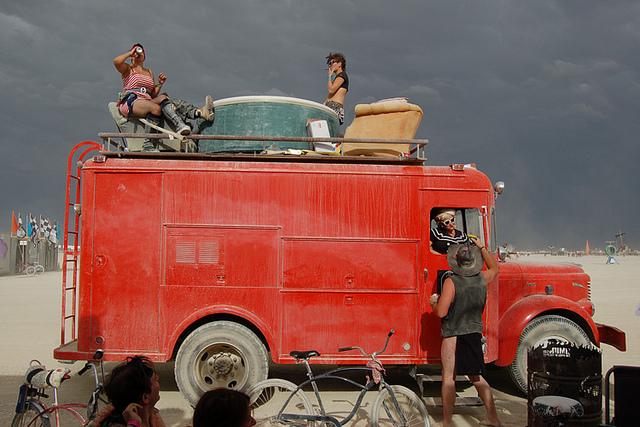Is the truck dirty or clean?
Short answer required. Dirty. What kind of climate are they in?
Quick response, please. Hot. How many people are in this picture?
Give a very brief answer. 6. 